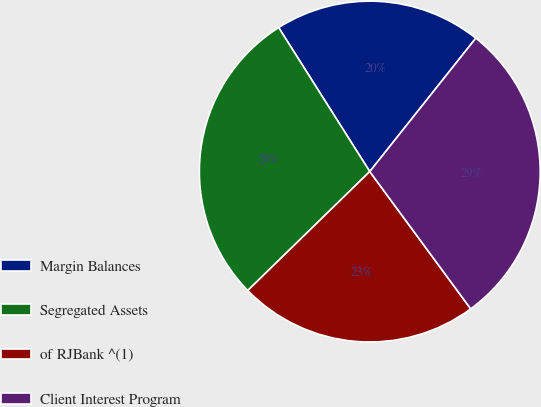<chart> <loc_0><loc_0><loc_500><loc_500><pie_chart><fcel>Margin Balances<fcel>Segregated Assets<fcel>of RJBank ^(1)<fcel>Client Interest Program<nl><fcel>19.67%<fcel>28.32%<fcel>22.79%<fcel>29.22%<nl></chart> 